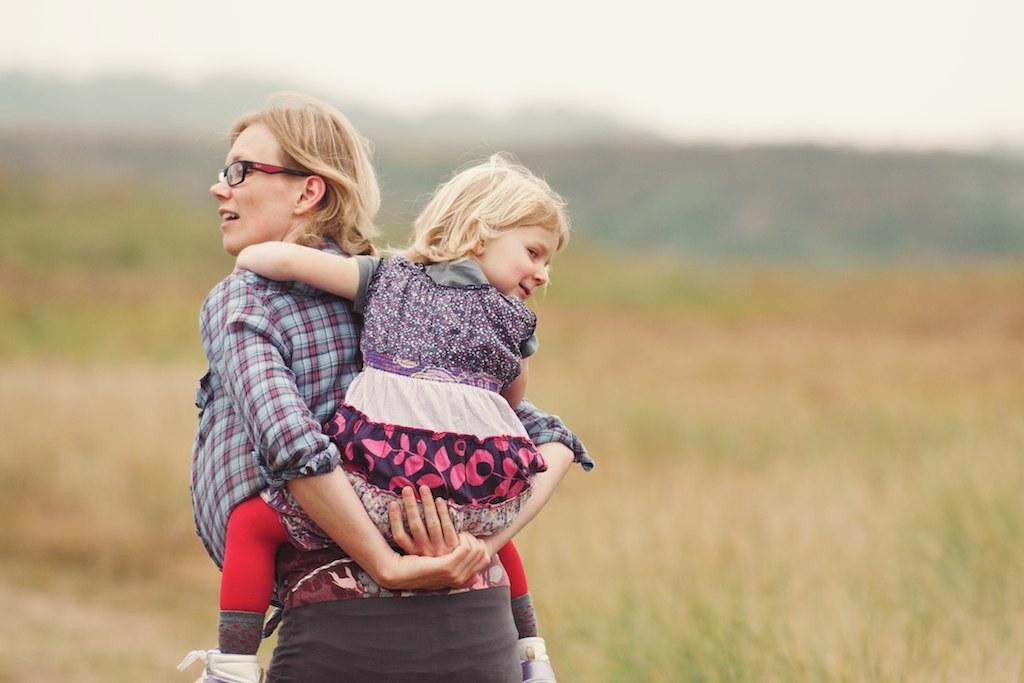In one or two sentences, can you explain what this image depicts? In this picture we can see a woman wore a spectacle and carrying a girl and in the background we can see the grass, mountains, sky and it is blur. 